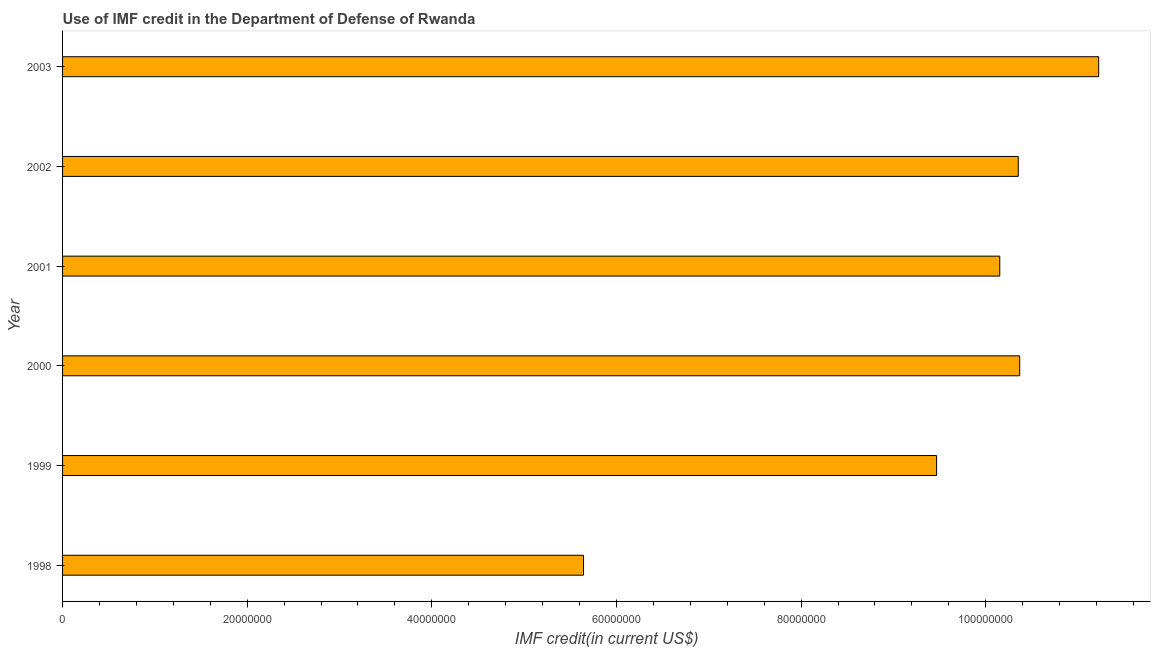What is the title of the graph?
Provide a short and direct response. Use of IMF credit in the Department of Defense of Rwanda. What is the label or title of the X-axis?
Your response must be concise. IMF credit(in current US$). What is the label or title of the Y-axis?
Provide a short and direct response. Year. What is the use of imf credit in dod in 2001?
Keep it short and to the point. 1.02e+08. Across all years, what is the maximum use of imf credit in dod?
Provide a short and direct response. 1.12e+08. Across all years, what is the minimum use of imf credit in dod?
Offer a terse response. 5.64e+07. In which year was the use of imf credit in dod maximum?
Your answer should be very brief. 2003. In which year was the use of imf credit in dod minimum?
Provide a succinct answer. 1998. What is the sum of the use of imf credit in dod?
Make the answer very short. 5.72e+08. What is the difference between the use of imf credit in dod in 1998 and 1999?
Your answer should be compact. -3.82e+07. What is the average use of imf credit in dod per year?
Offer a terse response. 9.53e+07. What is the median use of imf credit in dod?
Provide a short and direct response. 1.03e+08. In how many years, is the use of imf credit in dod greater than 24000000 US$?
Provide a succinct answer. 6. Do a majority of the years between 1999 and 2001 (inclusive) have use of imf credit in dod greater than 112000000 US$?
Keep it short and to the point. No. What is the ratio of the use of imf credit in dod in 2002 to that in 2003?
Offer a very short reply. 0.92. Is the use of imf credit in dod in 1998 less than that in 2002?
Make the answer very short. Yes. What is the difference between the highest and the second highest use of imf credit in dod?
Provide a succinct answer. 8.56e+06. What is the difference between the highest and the lowest use of imf credit in dod?
Provide a short and direct response. 5.58e+07. How many bars are there?
Keep it short and to the point. 6. Are all the bars in the graph horizontal?
Offer a very short reply. Yes. What is the difference between two consecutive major ticks on the X-axis?
Give a very brief answer. 2.00e+07. Are the values on the major ticks of X-axis written in scientific E-notation?
Keep it short and to the point. No. What is the IMF credit(in current US$) in 1998?
Ensure brevity in your answer.  5.64e+07. What is the IMF credit(in current US$) of 1999?
Give a very brief answer. 9.47e+07. What is the IMF credit(in current US$) in 2000?
Give a very brief answer. 1.04e+08. What is the IMF credit(in current US$) of 2001?
Your answer should be very brief. 1.02e+08. What is the IMF credit(in current US$) of 2002?
Provide a succinct answer. 1.04e+08. What is the IMF credit(in current US$) of 2003?
Your answer should be very brief. 1.12e+08. What is the difference between the IMF credit(in current US$) in 1998 and 1999?
Ensure brevity in your answer.  -3.82e+07. What is the difference between the IMF credit(in current US$) in 1998 and 2000?
Give a very brief answer. -4.72e+07. What is the difference between the IMF credit(in current US$) in 1998 and 2001?
Your answer should be compact. -4.51e+07. What is the difference between the IMF credit(in current US$) in 1998 and 2002?
Offer a terse response. -4.71e+07. What is the difference between the IMF credit(in current US$) in 1998 and 2003?
Your response must be concise. -5.58e+07. What is the difference between the IMF credit(in current US$) in 1999 and 2000?
Your response must be concise. -9.00e+06. What is the difference between the IMF credit(in current US$) in 1999 and 2001?
Ensure brevity in your answer.  -6.84e+06. What is the difference between the IMF credit(in current US$) in 1999 and 2002?
Your answer should be very brief. -8.85e+06. What is the difference between the IMF credit(in current US$) in 1999 and 2003?
Your answer should be compact. -1.76e+07. What is the difference between the IMF credit(in current US$) in 2000 and 2001?
Your response must be concise. 2.16e+06. What is the difference between the IMF credit(in current US$) in 2000 and 2002?
Make the answer very short. 1.54e+05. What is the difference between the IMF credit(in current US$) in 2000 and 2003?
Provide a short and direct response. -8.56e+06. What is the difference between the IMF credit(in current US$) in 2001 and 2002?
Ensure brevity in your answer.  -2.01e+06. What is the difference between the IMF credit(in current US$) in 2001 and 2003?
Offer a very short reply. -1.07e+07. What is the difference between the IMF credit(in current US$) in 2002 and 2003?
Make the answer very short. -8.71e+06. What is the ratio of the IMF credit(in current US$) in 1998 to that in 1999?
Ensure brevity in your answer.  0.6. What is the ratio of the IMF credit(in current US$) in 1998 to that in 2000?
Ensure brevity in your answer.  0.54. What is the ratio of the IMF credit(in current US$) in 1998 to that in 2001?
Your answer should be very brief. 0.56. What is the ratio of the IMF credit(in current US$) in 1998 to that in 2002?
Offer a very short reply. 0.55. What is the ratio of the IMF credit(in current US$) in 1998 to that in 2003?
Keep it short and to the point. 0.5. What is the ratio of the IMF credit(in current US$) in 1999 to that in 2000?
Ensure brevity in your answer.  0.91. What is the ratio of the IMF credit(in current US$) in 1999 to that in 2001?
Keep it short and to the point. 0.93. What is the ratio of the IMF credit(in current US$) in 1999 to that in 2002?
Provide a succinct answer. 0.92. What is the ratio of the IMF credit(in current US$) in 1999 to that in 2003?
Your answer should be compact. 0.84. What is the ratio of the IMF credit(in current US$) in 2000 to that in 2001?
Offer a terse response. 1.02. What is the ratio of the IMF credit(in current US$) in 2000 to that in 2003?
Provide a succinct answer. 0.92. What is the ratio of the IMF credit(in current US$) in 2001 to that in 2002?
Your response must be concise. 0.98. What is the ratio of the IMF credit(in current US$) in 2001 to that in 2003?
Provide a short and direct response. 0.91. What is the ratio of the IMF credit(in current US$) in 2002 to that in 2003?
Ensure brevity in your answer.  0.92. 